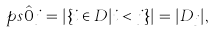Convert formula to latex. <formula><loc_0><loc_0><loc_500><loc_500>\ p s { \hat { 0 } } { j } = | \{ i \in D | i < j \} | = | D _ { j } | ,</formula> 